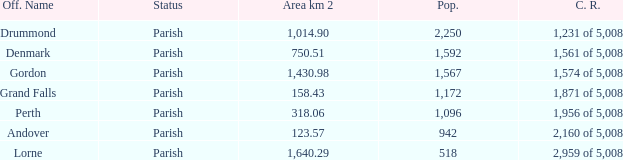What is the area of the parish with a population larger than 1,172 and a census ranking of 1,871 of 5,008? 0.0. 